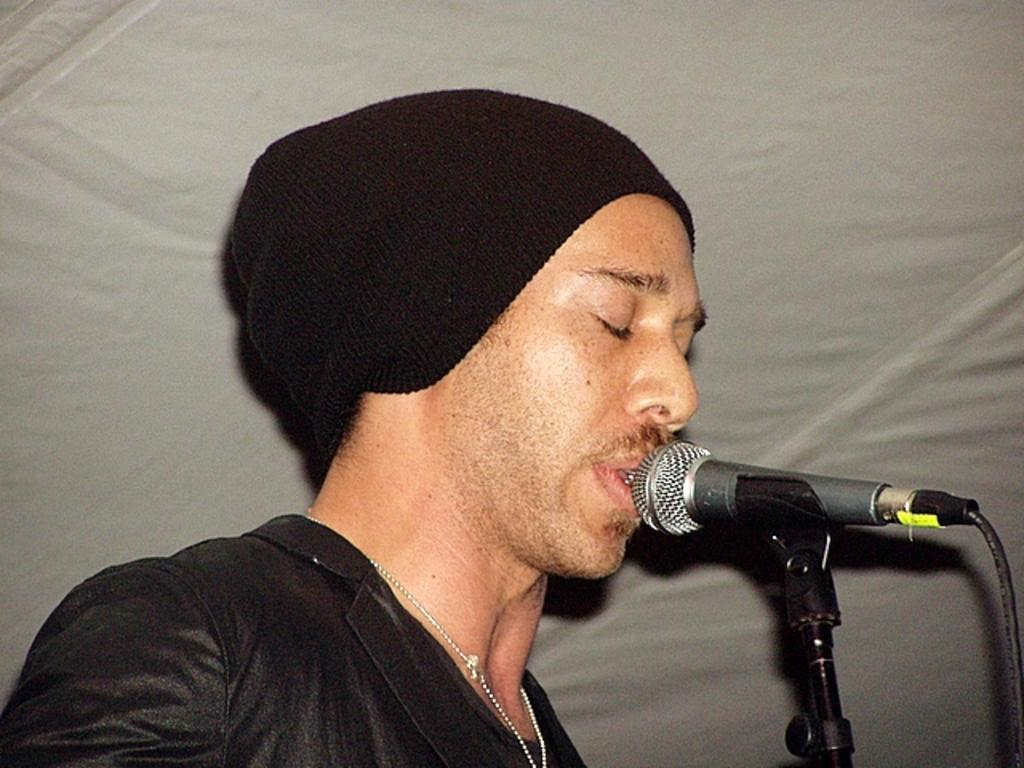What is the main subject of the image? There is a man standing in the middle of the image. What is visible behind the man? There is cloth visible behind the man. What object can be seen in the bottom right side of the image? There is a microphone in the bottom right side of the image. Can you tell me how many lakes are visible in the image? There are no lakes visible in the image; it features a man standing in front of cloth with a microphone nearby. What type of game is being played in the image? There is no game being played in the image; it shows a man standing in front of cloth with a microphone nearby. 